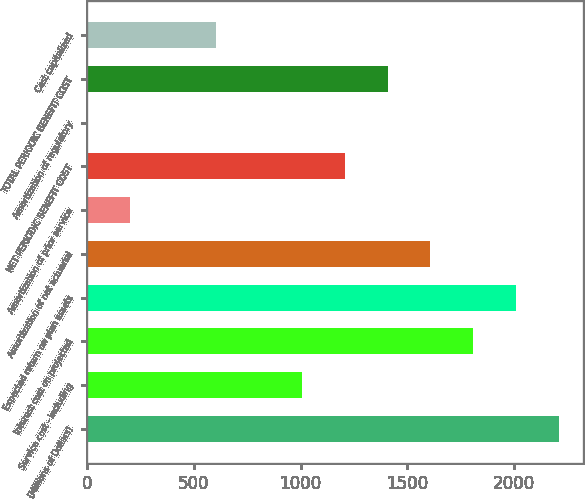<chart> <loc_0><loc_0><loc_500><loc_500><bar_chart><fcel>(Millions of Dollars)<fcel>Service cost - including<fcel>Interest cost on projected<fcel>Expected return on plan assets<fcel>Amortization of net actuarial<fcel>Amortization of prior service<fcel>NET PERIODIC BENEFIT COST<fcel>Amortization of regulatory<fcel>TOTAL PERIODIC BENEFIT COST<fcel>Cost capitalized<nl><fcel>2209.6<fcel>1006<fcel>1808.4<fcel>2009<fcel>1607.8<fcel>203.6<fcel>1206.6<fcel>3<fcel>1407.2<fcel>604.8<nl></chart> 